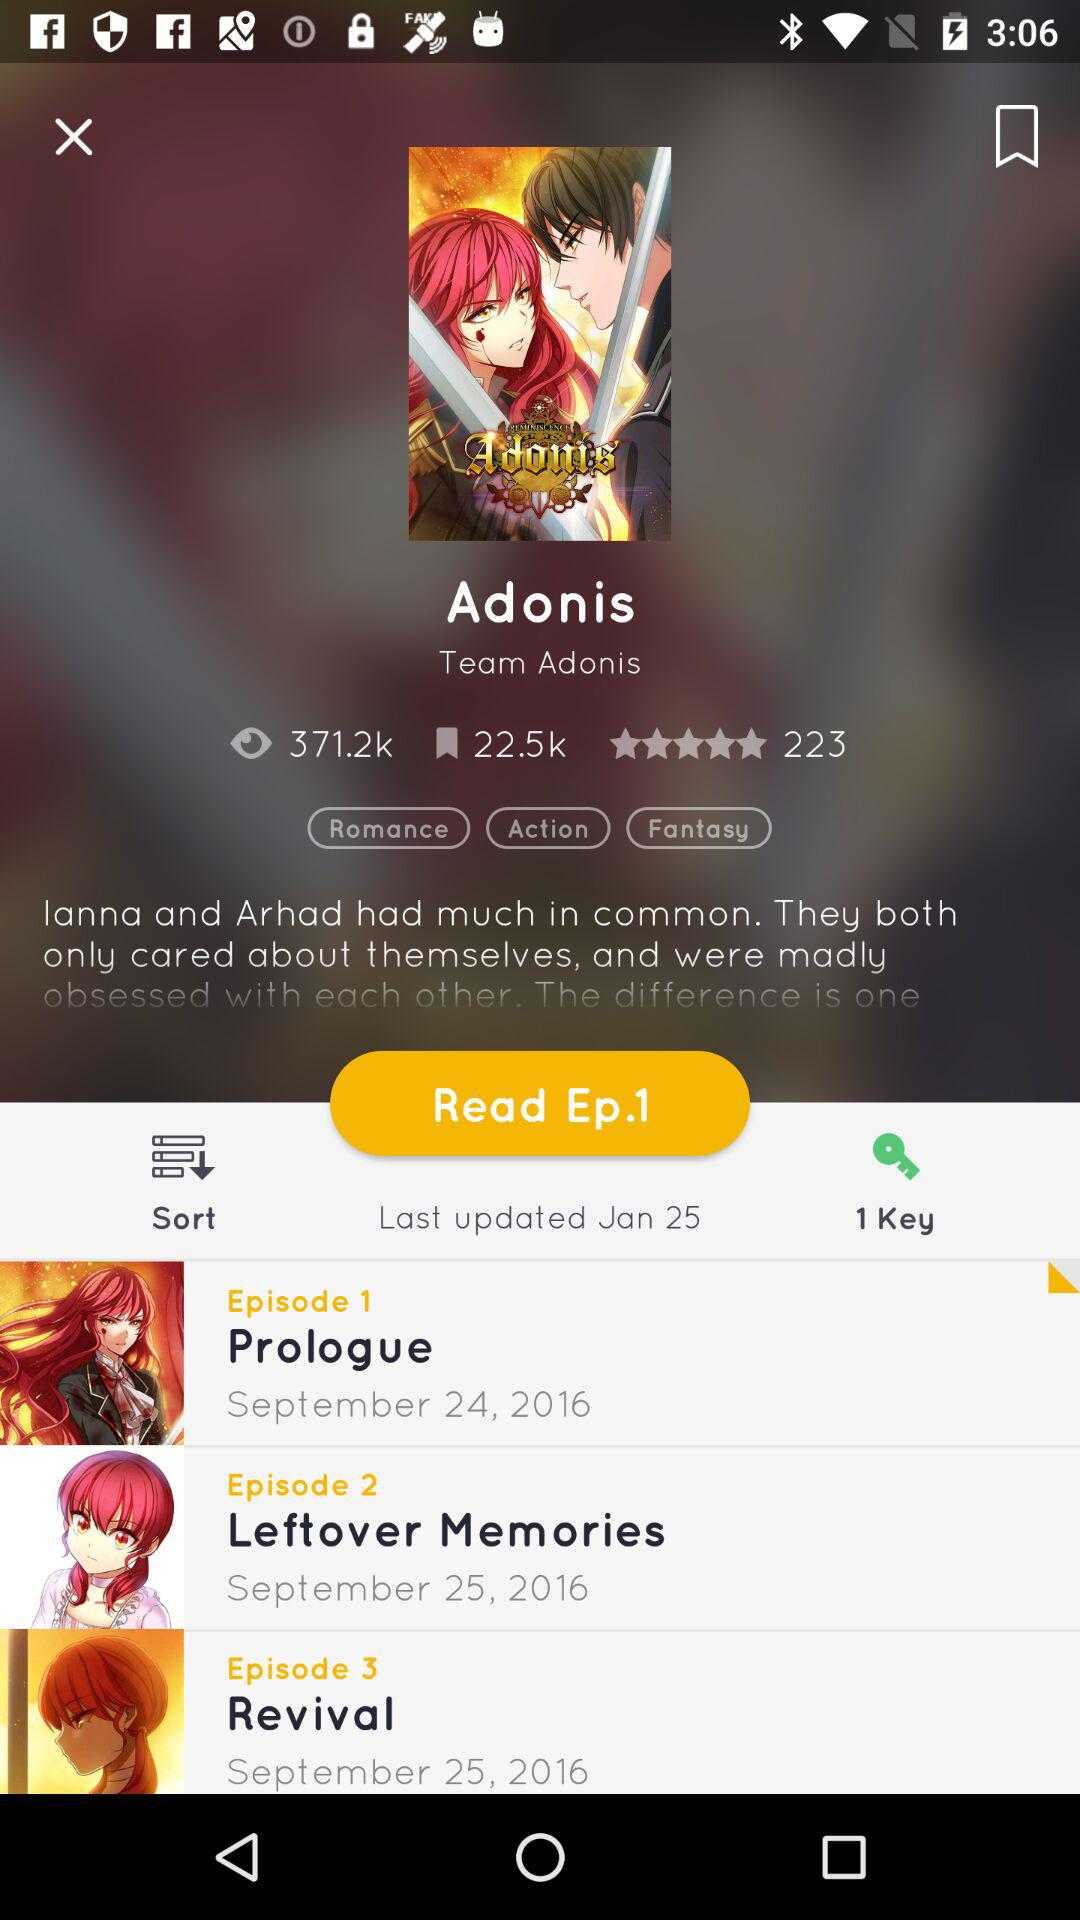When was Episode 1 released? Episode 1 was released on September 24, 2016. 